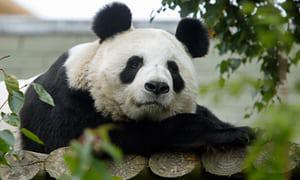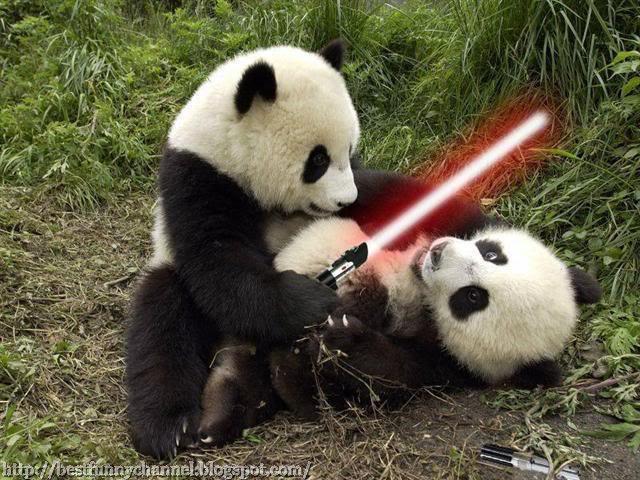The first image is the image on the left, the second image is the image on the right. Considering the images on both sides, is "a mother panda is with her infant on the grass" valid? Answer yes or no. No. The first image is the image on the left, the second image is the image on the right. Considering the images on both sides, is "Two pandas are actively play-fighting in one image, and the other image contains two pandas who are not in direct contact." valid? Answer yes or no. No. 